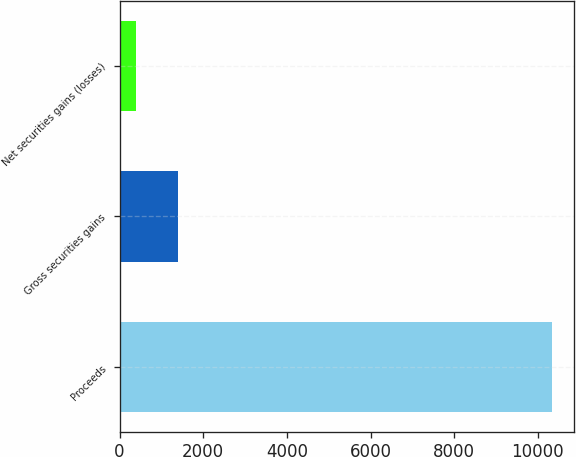<chart> <loc_0><loc_0><loc_500><loc_500><bar_chart><fcel>Proceeds<fcel>Gross securities gains<fcel>Net securities gains (losses)<nl><fcel>10340<fcel>1388.6<fcel>394<nl></chart> 